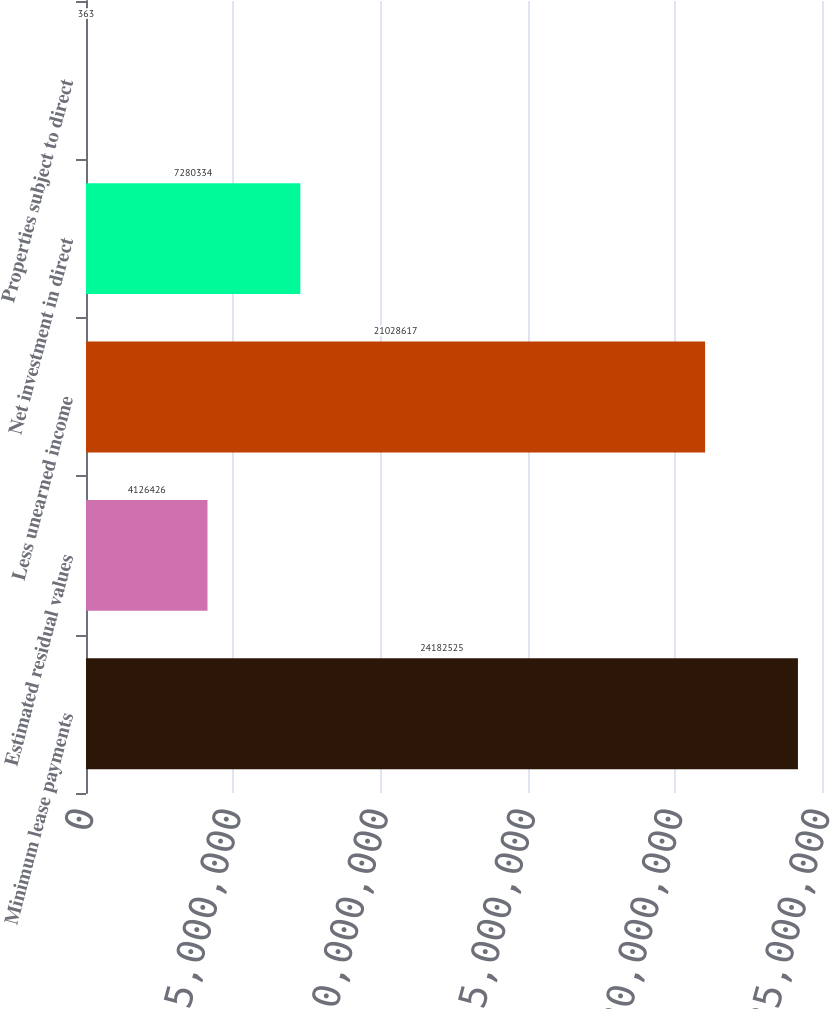Convert chart. <chart><loc_0><loc_0><loc_500><loc_500><bar_chart><fcel>Minimum lease payments<fcel>Estimated residual values<fcel>Less unearned income<fcel>Net investment in direct<fcel>Properties subject to direct<nl><fcel>2.41825e+07<fcel>4.12643e+06<fcel>2.10286e+07<fcel>7.28033e+06<fcel>363<nl></chart> 